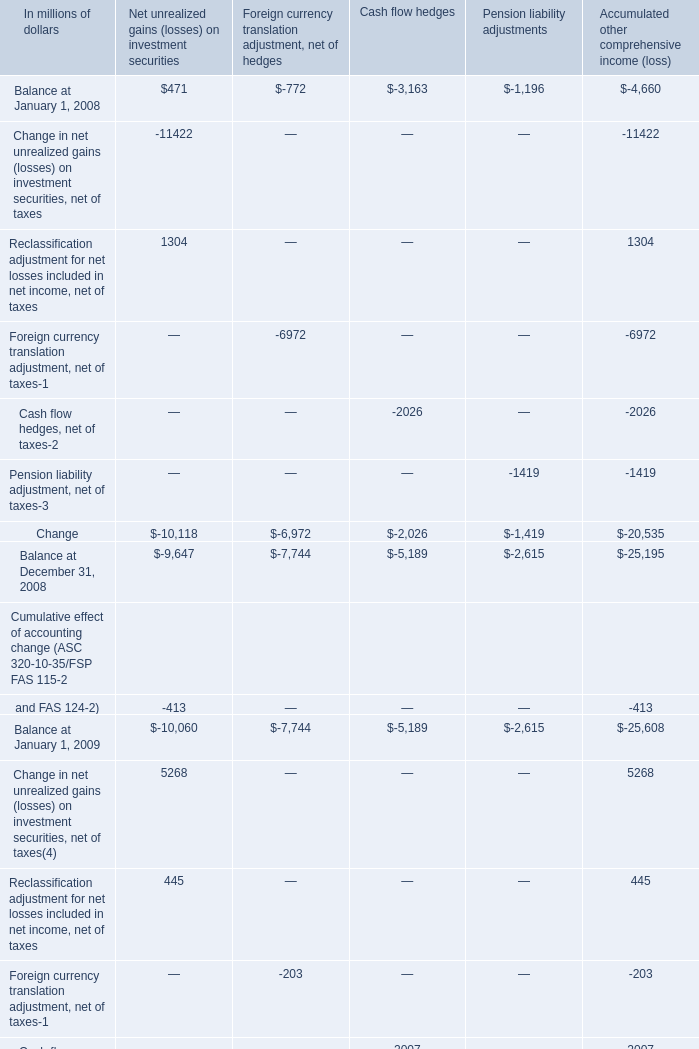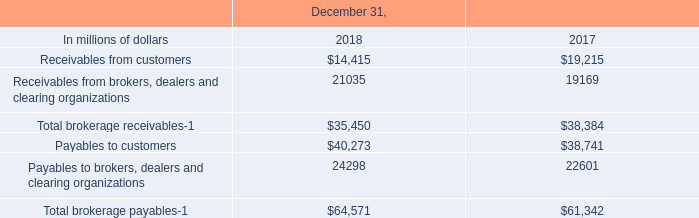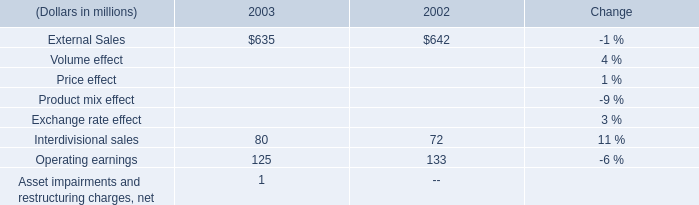If Balance at December 31 develops with the same growth rate in 2010, what will it reach in 2011 (in millions) 
Computations: ((1 + (((((-2395 + -7127) + -2650) + -4105) - (((-4347 + -7947) + -3182) + -3461)) / (((-4347 + -7947) + -3182) + -3461))) * (((-2395 + -7127) + -2650) + -4105))
Answer: -13990.63891. 